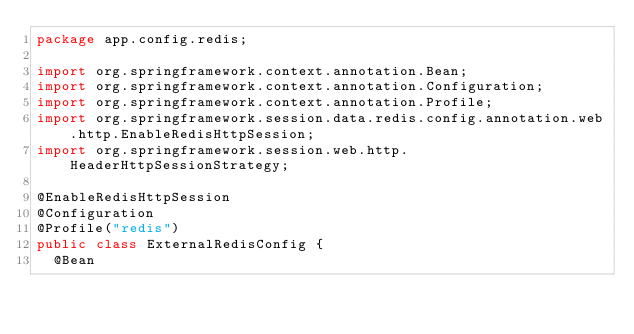<code> <loc_0><loc_0><loc_500><loc_500><_Java_>package app.config.redis;

import org.springframework.context.annotation.Bean;
import org.springframework.context.annotation.Configuration;
import org.springframework.context.annotation.Profile;
import org.springframework.session.data.redis.config.annotation.web.http.EnableRedisHttpSession;
import org.springframework.session.web.http.HeaderHttpSessionStrategy;

@EnableRedisHttpSession
@Configuration
@Profile("redis")
public class ExternalRedisConfig {
  @Bean</code> 